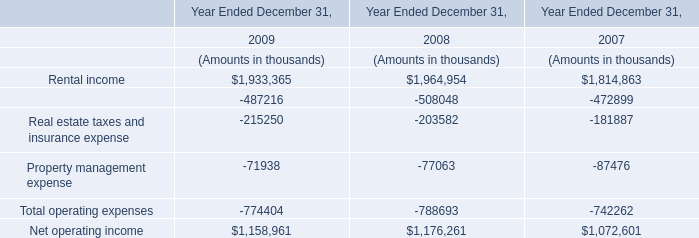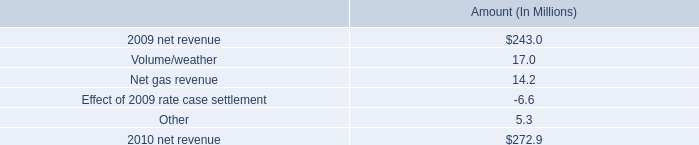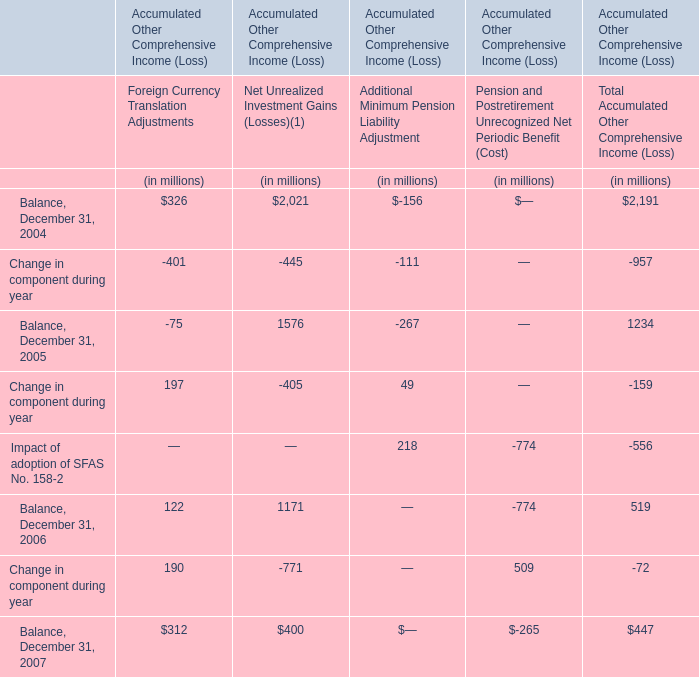What is the percentage of all Change in component during year that are positive to the total amount, in 2005 
Computations: ((197 + 49) / (((197 - 405) + 49) - 159))
Answer: -0.77358. 